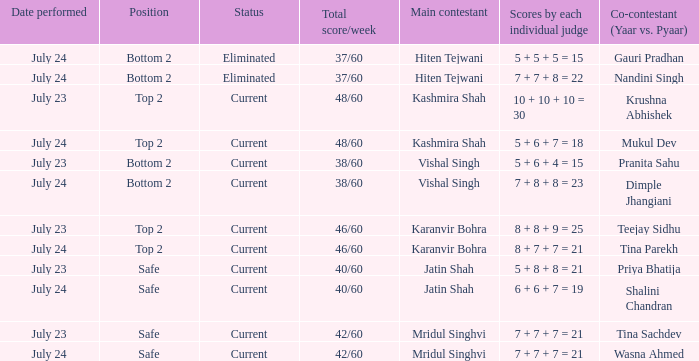What is Tina Sachdev's position? Safe. 